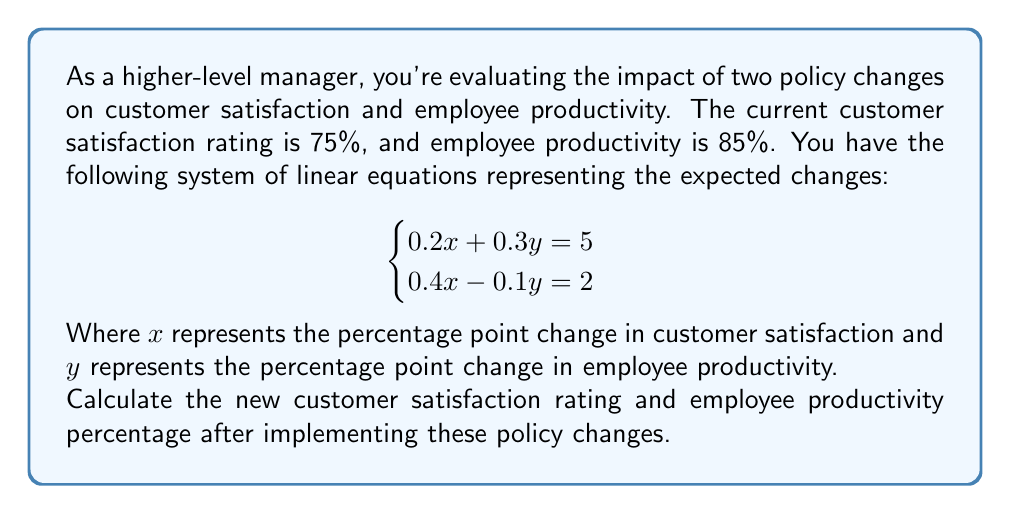Provide a solution to this math problem. To solve this problem, we'll follow these steps:

1) Solve the system of linear equations to find $x$ and $y$.
2) Add the changes to the current ratings.

Step 1: Solving the system of equations

We can use the substitution method:

From the first equation: $0.2x + 0.3y = 5$
Solve for $x$: $x = 25 - 1.5y$

Substitute this into the second equation:
$0.4(25 - 1.5y) - 0.1y = 2$
$10 - 0.6y - 0.1y = 2$
$10 - 0.7y = 2$
$-0.7y = -8$
$y = \frac{8}{0.7} \approx 11.43$

Now substitute $y$ back into $x = 25 - 1.5y$:
$x = 25 - 1.5(11.43) \approx 7.86$

Step 2: Adding changes to current ratings

Customer satisfaction: $75\% + 7.86\% = 82.86\%$
Employee productivity: $85\% + 11.43\% = 96.43\%$

Therefore, the new customer satisfaction rating will be approximately 82.86%, and the new employee productivity will be approximately 96.43%.
Answer: Customer satisfaction: 82.86%, Employee productivity: 96.43% 